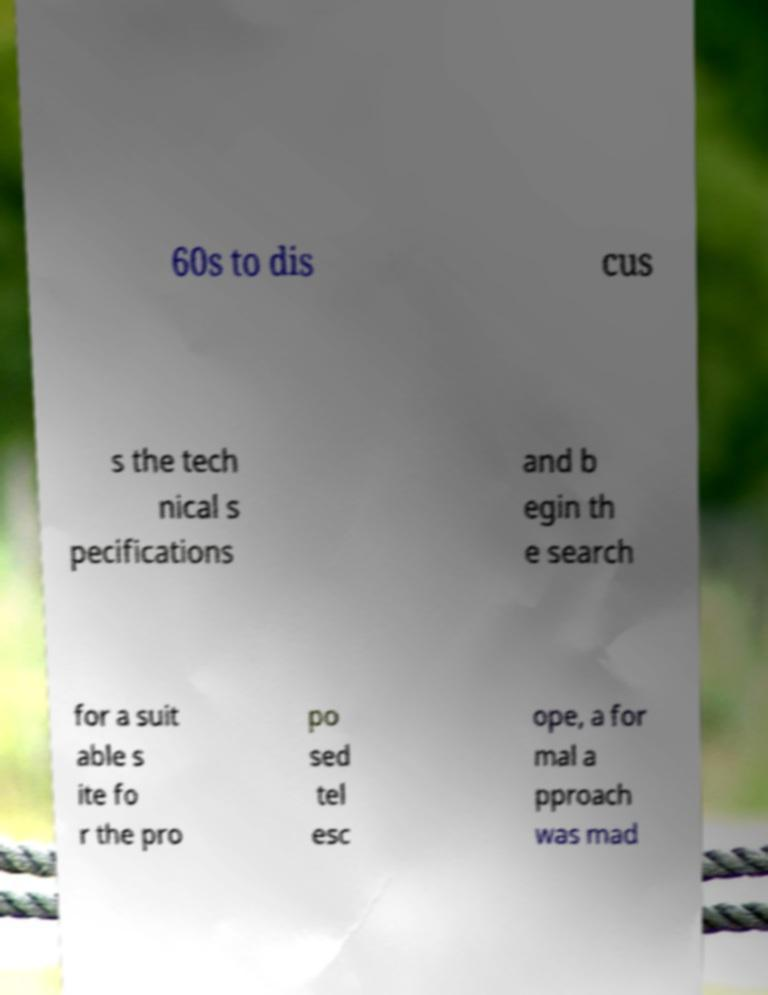Please read and relay the text visible in this image. What does it say? 60s to dis cus s the tech nical s pecifications and b egin th e search for a suit able s ite fo r the pro po sed tel esc ope, a for mal a pproach was mad 